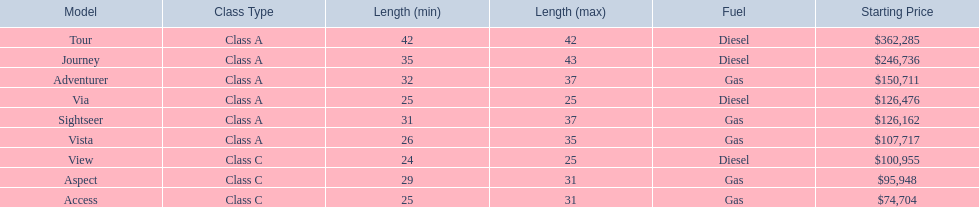What are all of the winnebago models? Tour, Journey, Adventurer, Via, Sightseer, Vista, View, Aspect, Access. What are their prices? $362,285, $246,736, $150,711, $126,476, $126,162, $107,717, $100,955, $95,948, $74,704. And which model costs the most? Tour. 